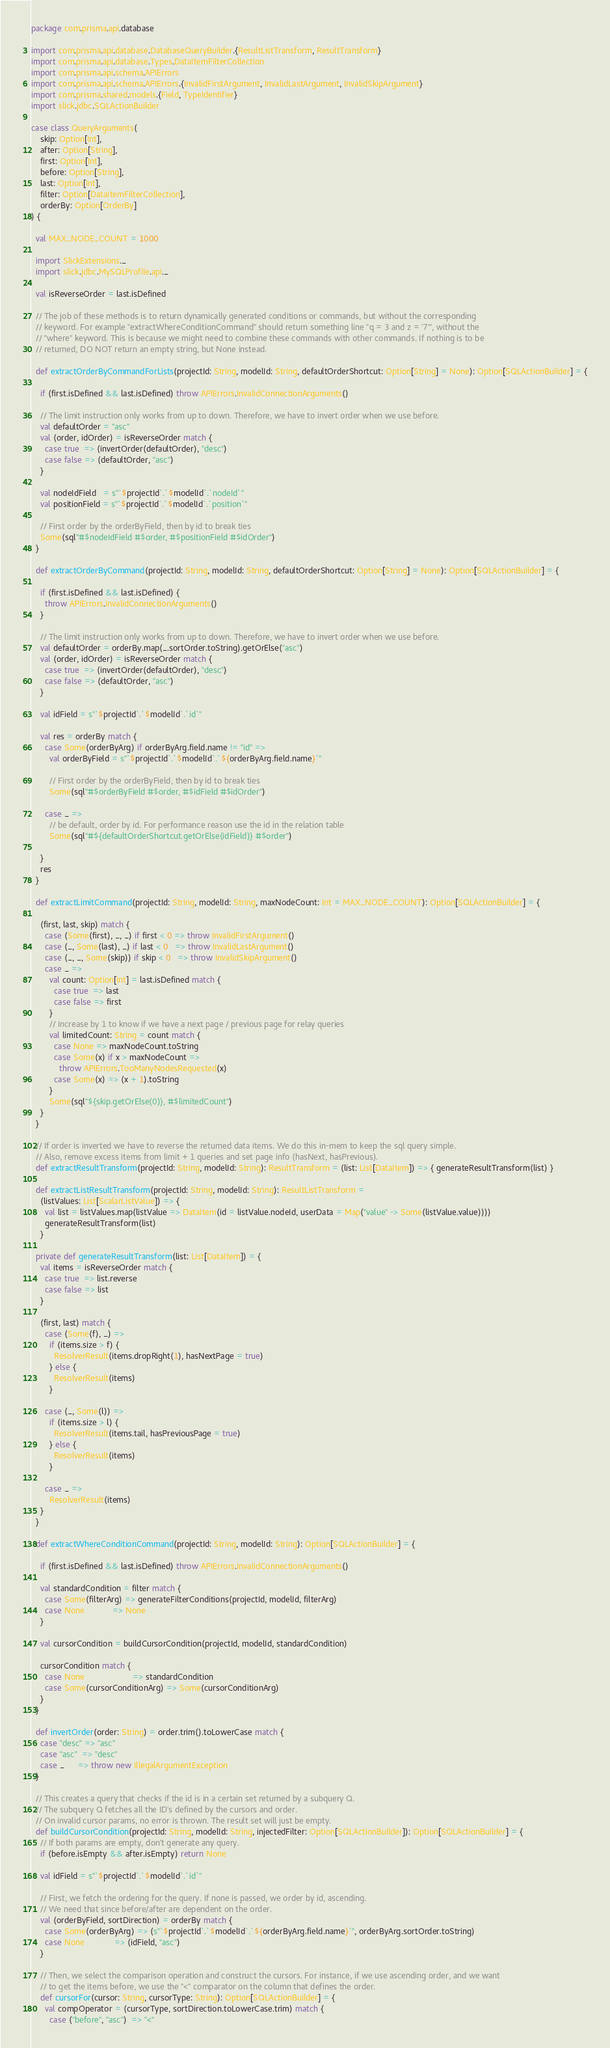Convert code to text. <code><loc_0><loc_0><loc_500><loc_500><_Scala_>package com.prisma.api.database

import com.prisma.api.database.DatabaseQueryBuilder.{ResultListTransform, ResultTransform}
import com.prisma.api.database.Types.DataItemFilterCollection
import com.prisma.api.schema.APIErrors
import com.prisma.api.schema.APIErrors.{InvalidFirstArgument, InvalidLastArgument, InvalidSkipArgument}
import com.prisma.shared.models.{Field, TypeIdentifier}
import slick.jdbc.SQLActionBuilder

case class QueryArguments(
    skip: Option[Int],
    after: Option[String],
    first: Option[Int],
    before: Option[String],
    last: Option[Int],
    filter: Option[DataItemFilterCollection],
    orderBy: Option[OrderBy]
) {

  val MAX_NODE_COUNT = 1000

  import SlickExtensions._
  import slick.jdbc.MySQLProfile.api._

  val isReverseOrder = last.isDefined

  // The job of these methods is to return dynamically generated conditions or commands, but without the corresponding
  // keyword. For example "extractWhereConditionCommand" should return something line "q = 3 and z = '7'", without the
  // "where" keyword. This is because we might need to combine these commands with other commands. If nothing is to be
  // returned, DO NOT return an empty string, but None instead.

  def extractOrderByCommandForLists(projectId: String, modelId: String, defaultOrderShortcut: Option[String] = None): Option[SQLActionBuilder] = {

    if (first.isDefined && last.isDefined) throw APIErrors.InvalidConnectionArguments()

    // The limit instruction only works from up to down. Therefore, we have to invert order when we use before.
    val defaultOrder = "asc"
    val (order, idOrder) = isReverseOrder match {
      case true  => (invertOrder(defaultOrder), "desc")
      case false => (defaultOrder, "asc")
    }

    val nodeIdField   = s"`$projectId`.`$modelId`.`nodeId`"
    val positionField = s"`$projectId`.`$modelId`.`position`"

    // First order by the orderByField, then by id to break ties
    Some(sql"#$nodeIdField #$order, #$positionField #$idOrder")
  }

  def extractOrderByCommand(projectId: String, modelId: String, defaultOrderShortcut: Option[String] = None): Option[SQLActionBuilder] = {

    if (first.isDefined && last.isDefined) {
      throw APIErrors.InvalidConnectionArguments()
    }

    // The limit instruction only works from up to down. Therefore, we have to invert order when we use before.
    val defaultOrder = orderBy.map(_.sortOrder.toString).getOrElse("asc")
    val (order, idOrder) = isReverseOrder match {
      case true  => (invertOrder(defaultOrder), "desc")
      case false => (defaultOrder, "asc")
    }

    val idField = s"`$projectId`.`$modelId`.`id`"

    val res = orderBy match {
      case Some(orderByArg) if orderByArg.field.name != "id" =>
        val orderByField = s"`$projectId`.`$modelId`.`${orderByArg.field.name}`"

        // First order by the orderByField, then by id to break ties
        Some(sql"#$orderByField #$order, #$idField #$idOrder")

      case _ =>
        // be default, order by id. For performance reason use the id in the relation table
        Some(sql"#${defaultOrderShortcut.getOrElse(idField)} #$order")

    }
    res
  }

  def extractLimitCommand(projectId: String, modelId: String, maxNodeCount: Int = MAX_NODE_COUNT): Option[SQLActionBuilder] = {

    (first, last, skip) match {
      case (Some(first), _, _) if first < 0 => throw InvalidFirstArgument()
      case (_, Some(last), _) if last < 0   => throw InvalidLastArgument()
      case (_, _, Some(skip)) if skip < 0   => throw InvalidSkipArgument()
      case _ =>
        val count: Option[Int] = last.isDefined match {
          case true  => last
          case false => first
        }
        // Increase by 1 to know if we have a next page / previous page for relay queries
        val limitedCount: String = count match {
          case None => maxNodeCount.toString
          case Some(x) if x > maxNodeCount =>
            throw APIErrors.TooManyNodesRequested(x)
          case Some(x) => (x + 1).toString
        }
        Some(sql"${skip.getOrElse(0)}, #$limitedCount")
    }
  }

  // If order is inverted we have to reverse the returned data items. We do this in-mem to keep the sql query simple.
  // Also, remove excess items from limit + 1 queries and set page info (hasNext, hasPrevious).
  def extractResultTransform(projectId: String, modelId: String): ResultTransform = (list: List[DataItem]) => { generateResultTransform(list) }

  def extractListResultTransform(projectId: String, modelId: String): ResultListTransform =
    (listValues: List[ScalarListValue]) => {
      val list = listValues.map(listValue => DataItem(id = listValue.nodeId, userData = Map("value" -> Some(listValue.value))))
      generateResultTransform(list)
    }

  private def generateResultTransform(list: List[DataItem]) = {
    val items = isReverseOrder match {
      case true  => list.reverse
      case false => list
    }

    (first, last) match {
      case (Some(f), _) =>
        if (items.size > f) {
          ResolverResult(items.dropRight(1), hasNextPage = true)
        } else {
          ResolverResult(items)
        }

      case (_, Some(l)) =>
        if (items.size > l) {
          ResolverResult(items.tail, hasPreviousPage = true)
        } else {
          ResolverResult(items)
        }

      case _ =>
        ResolverResult(items)
    }
  }

  def extractWhereConditionCommand(projectId: String, modelId: String): Option[SQLActionBuilder] = {

    if (first.isDefined && last.isDefined) throw APIErrors.InvalidConnectionArguments()

    val standardCondition = filter match {
      case Some(filterArg) => generateFilterConditions(projectId, modelId, filterArg)
      case None            => None
    }

    val cursorCondition = buildCursorCondition(projectId, modelId, standardCondition)

    cursorCondition match {
      case None                     => standardCondition
      case Some(cursorConditionArg) => Some(cursorConditionArg)
    }
  }

  def invertOrder(order: String) = order.trim().toLowerCase match {
    case "desc" => "asc"
    case "asc"  => "desc"
    case _      => throw new IllegalArgumentException
  }

  // This creates a query that checks if the id is in a certain set returned by a subquery Q.
  // The subquery Q fetches all the ID's defined by the cursors and order.
  // On invalid cursor params, no error is thrown. The result set will just be empty.
  def buildCursorCondition(projectId: String, modelId: String, injectedFilter: Option[SQLActionBuilder]): Option[SQLActionBuilder] = {
    // If both params are empty, don't generate any query.
    if (before.isEmpty && after.isEmpty) return None

    val idField = s"`$projectId`.`$modelId`.`id`"

    // First, we fetch the ordering for the query. If none is passed, we order by id, ascending.
    // We need that since before/after are dependent on the order.
    val (orderByField, sortDirection) = orderBy match {
      case Some(orderByArg) => (s"`$projectId`.`$modelId`.`${orderByArg.field.name}`", orderByArg.sortOrder.toString)
      case None             => (idField, "asc")
    }

    // Then, we select the comparison operation and construct the cursors. For instance, if we use ascending order, and we want
    // to get the items before, we use the "<" comparator on the column that defines the order.
    def cursorFor(cursor: String, cursorType: String): Option[SQLActionBuilder] = {
      val compOperator = (cursorType, sortDirection.toLowerCase.trim) match {
        case ("before", "asc")  => "<"</code> 